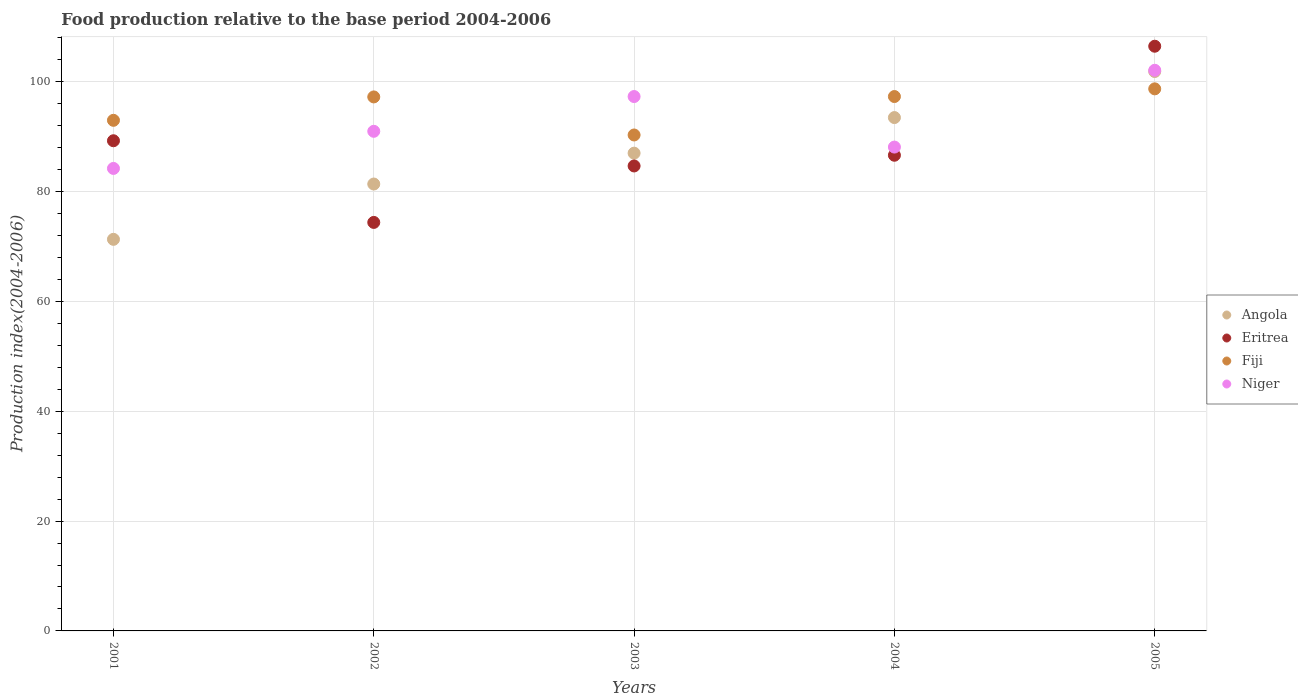How many different coloured dotlines are there?
Provide a succinct answer. 4. Is the number of dotlines equal to the number of legend labels?
Your answer should be compact. Yes. What is the food production index in Eritrea in 2001?
Provide a succinct answer. 89.25. Across all years, what is the maximum food production index in Niger?
Your answer should be very brief. 102.08. Across all years, what is the minimum food production index in Eritrea?
Offer a terse response. 74.38. In which year was the food production index in Niger maximum?
Your answer should be compact. 2005. In which year was the food production index in Angola minimum?
Give a very brief answer. 2001. What is the total food production index in Eritrea in the graph?
Your response must be concise. 441.36. What is the difference between the food production index in Angola in 2003 and that in 2005?
Ensure brevity in your answer.  -14.87. What is the difference between the food production index in Eritrea in 2002 and the food production index in Angola in 2005?
Ensure brevity in your answer.  -27.48. What is the average food production index in Niger per year?
Your answer should be very brief. 92.53. In the year 2003, what is the difference between the food production index in Angola and food production index in Fiji?
Keep it short and to the point. -3.31. In how many years, is the food production index in Angola greater than 4?
Ensure brevity in your answer.  5. What is the ratio of the food production index in Niger in 2003 to that in 2005?
Give a very brief answer. 0.95. What is the difference between the highest and the second highest food production index in Eritrea?
Make the answer very short. 17.21. What is the difference between the highest and the lowest food production index in Fiji?
Make the answer very short. 8.4. Is it the case that in every year, the sum of the food production index in Niger and food production index in Fiji  is greater than the sum of food production index in Angola and food production index in Eritrea?
Keep it short and to the point. No. Is the food production index in Fiji strictly greater than the food production index in Niger over the years?
Your answer should be very brief. No. How many dotlines are there?
Offer a very short reply. 4. What is the difference between two consecutive major ticks on the Y-axis?
Provide a succinct answer. 20. Are the values on the major ticks of Y-axis written in scientific E-notation?
Give a very brief answer. No. Does the graph contain grids?
Give a very brief answer. Yes. How are the legend labels stacked?
Give a very brief answer. Vertical. What is the title of the graph?
Keep it short and to the point. Food production relative to the base period 2004-2006. What is the label or title of the X-axis?
Your answer should be very brief. Years. What is the label or title of the Y-axis?
Your answer should be very brief. Production index(2004-2006). What is the Production index(2004-2006) in Angola in 2001?
Offer a very short reply. 71.3. What is the Production index(2004-2006) of Eritrea in 2001?
Offer a very short reply. 89.25. What is the Production index(2004-2006) in Fiji in 2001?
Keep it short and to the point. 92.97. What is the Production index(2004-2006) of Niger in 2001?
Offer a very short reply. 84.21. What is the Production index(2004-2006) in Angola in 2002?
Ensure brevity in your answer.  81.37. What is the Production index(2004-2006) of Eritrea in 2002?
Provide a succinct answer. 74.38. What is the Production index(2004-2006) of Fiji in 2002?
Give a very brief answer. 97.23. What is the Production index(2004-2006) in Niger in 2002?
Keep it short and to the point. 90.97. What is the Production index(2004-2006) in Angola in 2003?
Provide a succinct answer. 86.99. What is the Production index(2004-2006) in Eritrea in 2003?
Your answer should be very brief. 84.66. What is the Production index(2004-2006) of Fiji in 2003?
Your answer should be very brief. 90.3. What is the Production index(2004-2006) in Niger in 2003?
Ensure brevity in your answer.  97.3. What is the Production index(2004-2006) in Angola in 2004?
Your answer should be compact. 93.47. What is the Production index(2004-2006) in Eritrea in 2004?
Offer a very short reply. 86.61. What is the Production index(2004-2006) of Fiji in 2004?
Your answer should be very brief. 97.3. What is the Production index(2004-2006) in Niger in 2004?
Ensure brevity in your answer.  88.1. What is the Production index(2004-2006) in Angola in 2005?
Provide a succinct answer. 101.86. What is the Production index(2004-2006) in Eritrea in 2005?
Make the answer very short. 106.46. What is the Production index(2004-2006) in Fiji in 2005?
Provide a succinct answer. 98.7. What is the Production index(2004-2006) of Niger in 2005?
Offer a terse response. 102.08. Across all years, what is the maximum Production index(2004-2006) in Angola?
Keep it short and to the point. 101.86. Across all years, what is the maximum Production index(2004-2006) in Eritrea?
Your response must be concise. 106.46. Across all years, what is the maximum Production index(2004-2006) of Fiji?
Give a very brief answer. 98.7. Across all years, what is the maximum Production index(2004-2006) of Niger?
Give a very brief answer. 102.08. Across all years, what is the minimum Production index(2004-2006) of Angola?
Keep it short and to the point. 71.3. Across all years, what is the minimum Production index(2004-2006) in Eritrea?
Keep it short and to the point. 74.38. Across all years, what is the minimum Production index(2004-2006) in Fiji?
Offer a terse response. 90.3. Across all years, what is the minimum Production index(2004-2006) of Niger?
Give a very brief answer. 84.21. What is the total Production index(2004-2006) of Angola in the graph?
Offer a very short reply. 434.99. What is the total Production index(2004-2006) in Eritrea in the graph?
Your response must be concise. 441.36. What is the total Production index(2004-2006) of Fiji in the graph?
Provide a succinct answer. 476.5. What is the total Production index(2004-2006) in Niger in the graph?
Provide a short and direct response. 462.66. What is the difference between the Production index(2004-2006) in Angola in 2001 and that in 2002?
Offer a very short reply. -10.07. What is the difference between the Production index(2004-2006) in Eritrea in 2001 and that in 2002?
Provide a short and direct response. 14.87. What is the difference between the Production index(2004-2006) in Fiji in 2001 and that in 2002?
Provide a succinct answer. -4.26. What is the difference between the Production index(2004-2006) of Niger in 2001 and that in 2002?
Your answer should be very brief. -6.76. What is the difference between the Production index(2004-2006) in Angola in 2001 and that in 2003?
Your answer should be very brief. -15.69. What is the difference between the Production index(2004-2006) in Eritrea in 2001 and that in 2003?
Offer a terse response. 4.59. What is the difference between the Production index(2004-2006) in Fiji in 2001 and that in 2003?
Your answer should be very brief. 2.67. What is the difference between the Production index(2004-2006) of Niger in 2001 and that in 2003?
Offer a very short reply. -13.09. What is the difference between the Production index(2004-2006) in Angola in 2001 and that in 2004?
Make the answer very short. -22.17. What is the difference between the Production index(2004-2006) of Eritrea in 2001 and that in 2004?
Your response must be concise. 2.64. What is the difference between the Production index(2004-2006) of Fiji in 2001 and that in 2004?
Keep it short and to the point. -4.33. What is the difference between the Production index(2004-2006) of Niger in 2001 and that in 2004?
Make the answer very short. -3.89. What is the difference between the Production index(2004-2006) of Angola in 2001 and that in 2005?
Make the answer very short. -30.56. What is the difference between the Production index(2004-2006) of Eritrea in 2001 and that in 2005?
Your answer should be very brief. -17.21. What is the difference between the Production index(2004-2006) of Fiji in 2001 and that in 2005?
Your answer should be very brief. -5.73. What is the difference between the Production index(2004-2006) in Niger in 2001 and that in 2005?
Give a very brief answer. -17.87. What is the difference between the Production index(2004-2006) of Angola in 2002 and that in 2003?
Your response must be concise. -5.62. What is the difference between the Production index(2004-2006) in Eritrea in 2002 and that in 2003?
Keep it short and to the point. -10.28. What is the difference between the Production index(2004-2006) of Fiji in 2002 and that in 2003?
Offer a terse response. 6.93. What is the difference between the Production index(2004-2006) of Niger in 2002 and that in 2003?
Give a very brief answer. -6.33. What is the difference between the Production index(2004-2006) in Angola in 2002 and that in 2004?
Make the answer very short. -12.1. What is the difference between the Production index(2004-2006) in Eritrea in 2002 and that in 2004?
Provide a short and direct response. -12.23. What is the difference between the Production index(2004-2006) in Fiji in 2002 and that in 2004?
Keep it short and to the point. -0.07. What is the difference between the Production index(2004-2006) in Niger in 2002 and that in 2004?
Offer a very short reply. 2.87. What is the difference between the Production index(2004-2006) in Angola in 2002 and that in 2005?
Offer a very short reply. -20.49. What is the difference between the Production index(2004-2006) of Eritrea in 2002 and that in 2005?
Your answer should be compact. -32.08. What is the difference between the Production index(2004-2006) of Fiji in 2002 and that in 2005?
Your response must be concise. -1.47. What is the difference between the Production index(2004-2006) in Niger in 2002 and that in 2005?
Provide a short and direct response. -11.11. What is the difference between the Production index(2004-2006) in Angola in 2003 and that in 2004?
Provide a short and direct response. -6.48. What is the difference between the Production index(2004-2006) in Eritrea in 2003 and that in 2004?
Offer a very short reply. -1.95. What is the difference between the Production index(2004-2006) of Niger in 2003 and that in 2004?
Make the answer very short. 9.2. What is the difference between the Production index(2004-2006) of Angola in 2003 and that in 2005?
Your answer should be compact. -14.87. What is the difference between the Production index(2004-2006) of Eritrea in 2003 and that in 2005?
Your answer should be compact. -21.8. What is the difference between the Production index(2004-2006) of Niger in 2003 and that in 2005?
Keep it short and to the point. -4.78. What is the difference between the Production index(2004-2006) of Angola in 2004 and that in 2005?
Make the answer very short. -8.39. What is the difference between the Production index(2004-2006) of Eritrea in 2004 and that in 2005?
Offer a very short reply. -19.85. What is the difference between the Production index(2004-2006) in Fiji in 2004 and that in 2005?
Make the answer very short. -1.4. What is the difference between the Production index(2004-2006) of Niger in 2004 and that in 2005?
Your answer should be compact. -13.98. What is the difference between the Production index(2004-2006) in Angola in 2001 and the Production index(2004-2006) in Eritrea in 2002?
Provide a short and direct response. -3.08. What is the difference between the Production index(2004-2006) in Angola in 2001 and the Production index(2004-2006) in Fiji in 2002?
Your answer should be very brief. -25.93. What is the difference between the Production index(2004-2006) of Angola in 2001 and the Production index(2004-2006) of Niger in 2002?
Give a very brief answer. -19.67. What is the difference between the Production index(2004-2006) of Eritrea in 2001 and the Production index(2004-2006) of Fiji in 2002?
Provide a short and direct response. -7.98. What is the difference between the Production index(2004-2006) in Eritrea in 2001 and the Production index(2004-2006) in Niger in 2002?
Provide a short and direct response. -1.72. What is the difference between the Production index(2004-2006) in Fiji in 2001 and the Production index(2004-2006) in Niger in 2002?
Keep it short and to the point. 2. What is the difference between the Production index(2004-2006) in Angola in 2001 and the Production index(2004-2006) in Eritrea in 2003?
Your response must be concise. -13.36. What is the difference between the Production index(2004-2006) of Angola in 2001 and the Production index(2004-2006) of Fiji in 2003?
Ensure brevity in your answer.  -19. What is the difference between the Production index(2004-2006) in Eritrea in 2001 and the Production index(2004-2006) in Fiji in 2003?
Provide a succinct answer. -1.05. What is the difference between the Production index(2004-2006) of Eritrea in 2001 and the Production index(2004-2006) of Niger in 2003?
Ensure brevity in your answer.  -8.05. What is the difference between the Production index(2004-2006) of Fiji in 2001 and the Production index(2004-2006) of Niger in 2003?
Keep it short and to the point. -4.33. What is the difference between the Production index(2004-2006) in Angola in 2001 and the Production index(2004-2006) in Eritrea in 2004?
Give a very brief answer. -15.31. What is the difference between the Production index(2004-2006) in Angola in 2001 and the Production index(2004-2006) in Niger in 2004?
Ensure brevity in your answer.  -16.8. What is the difference between the Production index(2004-2006) of Eritrea in 2001 and the Production index(2004-2006) of Fiji in 2004?
Your answer should be compact. -8.05. What is the difference between the Production index(2004-2006) in Eritrea in 2001 and the Production index(2004-2006) in Niger in 2004?
Give a very brief answer. 1.15. What is the difference between the Production index(2004-2006) of Fiji in 2001 and the Production index(2004-2006) of Niger in 2004?
Provide a succinct answer. 4.87. What is the difference between the Production index(2004-2006) in Angola in 2001 and the Production index(2004-2006) in Eritrea in 2005?
Provide a succinct answer. -35.16. What is the difference between the Production index(2004-2006) in Angola in 2001 and the Production index(2004-2006) in Fiji in 2005?
Provide a succinct answer. -27.4. What is the difference between the Production index(2004-2006) of Angola in 2001 and the Production index(2004-2006) of Niger in 2005?
Keep it short and to the point. -30.78. What is the difference between the Production index(2004-2006) in Eritrea in 2001 and the Production index(2004-2006) in Fiji in 2005?
Your answer should be very brief. -9.45. What is the difference between the Production index(2004-2006) of Eritrea in 2001 and the Production index(2004-2006) of Niger in 2005?
Your response must be concise. -12.83. What is the difference between the Production index(2004-2006) of Fiji in 2001 and the Production index(2004-2006) of Niger in 2005?
Offer a terse response. -9.11. What is the difference between the Production index(2004-2006) in Angola in 2002 and the Production index(2004-2006) in Eritrea in 2003?
Keep it short and to the point. -3.29. What is the difference between the Production index(2004-2006) of Angola in 2002 and the Production index(2004-2006) of Fiji in 2003?
Your answer should be very brief. -8.93. What is the difference between the Production index(2004-2006) of Angola in 2002 and the Production index(2004-2006) of Niger in 2003?
Offer a terse response. -15.93. What is the difference between the Production index(2004-2006) of Eritrea in 2002 and the Production index(2004-2006) of Fiji in 2003?
Your answer should be compact. -15.92. What is the difference between the Production index(2004-2006) of Eritrea in 2002 and the Production index(2004-2006) of Niger in 2003?
Provide a succinct answer. -22.92. What is the difference between the Production index(2004-2006) in Fiji in 2002 and the Production index(2004-2006) in Niger in 2003?
Your answer should be very brief. -0.07. What is the difference between the Production index(2004-2006) in Angola in 2002 and the Production index(2004-2006) in Eritrea in 2004?
Offer a terse response. -5.24. What is the difference between the Production index(2004-2006) in Angola in 2002 and the Production index(2004-2006) in Fiji in 2004?
Keep it short and to the point. -15.93. What is the difference between the Production index(2004-2006) in Angola in 2002 and the Production index(2004-2006) in Niger in 2004?
Provide a succinct answer. -6.73. What is the difference between the Production index(2004-2006) in Eritrea in 2002 and the Production index(2004-2006) in Fiji in 2004?
Offer a terse response. -22.92. What is the difference between the Production index(2004-2006) of Eritrea in 2002 and the Production index(2004-2006) of Niger in 2004?
Offer a terse response. -13.72. What is the difference between the Production index(2004-2006) in Fiji in 2002 and the Production index(2004-2006) in Niger in 2004?
Ensure brevity in your answer.  9.13. What is the difference between the Production index(2004-2006) in Angola in 2002 and the Production index(2004-2006) in Eritrea in 2005?
Your response must be concise. -25.09. What is the difference between the Production index(2004-2006) in Angola in 2002 and the Production index(2004-2006) in Fiji in 2005?
Keep it short and to the point. -17.33. What is the difference between the Production index(2004-2006) in Angola in 2002 and the Production index(2004-2006) in Niger in 2005?
Give a very brief answer. -20.71. What is the difference between the Production index(2004-2006) of Eritrea in 2002 and the Production index(2004-2006) of Fiji in 2005?
Provide a succinct answer. -24.32. What is the difference between the Production index(2004-2006) in Eritrea in 2002 and the Production index(2004-2006) in Niger in 2005?
Ensure brevity in your answer.  -27.7. What is the difference between the Production index(2004-2006) in Fiji in 2002 and the Production index(2004-2006) in Niger in 2005?
Give a very brief answer. -4.85. What is the difference between the Production index(2004-2006) in Angola in 2003 and the Production index(2004-2006) in Eritrea in 2004?
Your answer should be compact. 0.38. What is the difference between the Production index(2004-2006) in Angola in 2003 and the Production index(2004-2006) in Fiji in 2004?
Your response must be concise. -10.31. What is the difference between the Production index(2004-2006) of Angola in 2003 and the Production index(2004-2006) of Niger in 2004?
Ensure brevity in your answer.  -1.11. What is the difference between the Production index(2004-2006) of Eritrea in 2003 and the Production index(2004-2006) of Fiji in 2004?
Provide a succinct answer. -12.64. What is the difference between the Production index(2004-2006) of Eritrea in 2003 and the Production index(2004-2006) of Niger in 2004?
Keep it short and to the point. -3.44. What is the difference between the Production index(2004-2006) of Angola in 2003 and the Production index(2004-2006) of Eritrea in 2005?
Give a very brief answer. -19.47. What is the difference between the Production index(2004-2006) of Angola in 2003 and the Production index(2004-2006) of Fiji in 2005?
Make the answer very short. -11.71. What is the difference between the Production index(2004-2006) of Angola in 2003 and the Production index(2004-2006) of Niger in 2005?
Ensure brevity in your answer.  -15.09. What is the difference between the Production index(2004-2006) in Eritrea in 2003 and the Production index(2004-2006) in Fiji in 2005?
Provide a succinct answer. -14.04. What is the difference between the Production index(2004-2006) of Eritrea in 2003 and the Production index(2004-2006) of Niger in 2005?
Provide a short and direct response. -17.42. What is the difference between the Production index(2004-2006) in Fiji in 2003 and the Production index(2004-2006) in Niger in 2005?
Make the answer very short. -11.78. What is the difference between the Production index(2004-2006) of Angola in 2004 and the Production index(2004-2006) of Eritrea in 2005?
Give a very brief answer. -12.99. What is the difference between the Production index(2004-2006) of Angola in 2004 and the Production index(2004-2006) of Fiji in 2005?
Offer a very short reply. -5.23. What is the difference between the Production index(2004-2006) in Angola in 2004 and the Production index(2004-2006) in Niger in 2005?
Your response must be concise. -8.61. What is the difference between the Production index(2004-2006) in Eritrea in 2004 and the Production index(2004-2006) in Fiji in 2005?
Provide a short and direct response. -12.09. What is the difference between the Production index(2004-2006) of Eritrea in 2004 and the Production index(2004-2006) of Niger in 2005?
Your response must be concise. -15.47. What is the difference between the Production index(2004-2006) of Fiji in 2004 and the Production index(2004-2006) of Niger in 2005?
Make the answer very short. -4.78. What is the average Production index(2004-2006) in Angola per year?
Provide a short and direct response. 87. What is the average Production index(2004-2006) in Eritrea per year?
Offer a very short reply. 88.27. What is the average Production index(2004-2006) of Fiji per year?
Offer a terse response. 95.3. What is the average Production index(2004-2006) in Niger per year?
Your response must be concise. 92.53. In the year 2001, what is the difference between the Production index(2004-2006) of Angola and Production index(2004-2006) of Eritrea?
Your response must be concise. -17.95. In the year 2001, what is the difference between the Production index(2004-2006) in Angola and Production index(2004-2006) in Fiji?
Offer a terse response. -21.67. In the year 2001, what is the difference between the Production index(2004-2006) of Angola and Production index(2004-2006) of Niger?
Offer a terse response. -12.91. In the year 2001, what is the difference between the Production index(2004-2006) in Eritrea and Production index(2004-2006) in Fiji?
Keep it short and to the point. -3.72. In the year 2001, what is the difference between the Production index(2004-2006) in Eritrea and Production index(2004-2006) in Niger?
Provide a succinct answer. 5.04. In the year 2001, what is the difference between the Production index(2004-2006) of Fiji and Production index(2004-2006) of Niger?
Provide a short and direct response. 8.76. In the year 2002, what is the difference between the Production index(2004-2006) of Angola and Production index(2004-2006) of Eritrea?
Offer a very short reply. 6.99. In the year 2002, what is the difference between the Production index(2004-2006) in Angola and Production index(2004-2006) in Fiji?
Offer a very short reply. -15.86. In the year 2002, what is the difference between the Production index(2004-2006) of Eritrea and Production index(2004-2006) of Fiji?
Make the answer very short. -22.85. In the year 2002, what is the difference between the Production index(2004-2006) of Eritrea and Production index(2004-2006) of Niger?
Provide a succinct answer. -16.59. In the year 2002, what is the difference between the Production index(2004-2006) of Fiji and Production index(2004-2006) of Niger?
Ensure brevity in your answer.  6.26. In the year 2003, what is the difference between the Production index(2004-2006) in Angola and Production index(2004-2006) in Eritrea?
Your answer should be compact. 2.33. In the year 2003, what is the difference between the Production index(2004-2006) in Angola and Production index(2004-2006) in Fiji?
Your response must be concise. -3.31. In the year 2003, what is the difference between the Production index(2004-2006) in Angola and Production index(2004-2006) in Niger?
Your response must be concise. -10.31. In the year 2003, what is the difference between the Production index(2004-2006) in Eritrea and Production index(2004-2006) in Fiji?
Give a very brief answer. -5.64. In the year 2003, what is the difference between the Production index(2004-2006) in Eritrea and Production index(2004-2006) in Niger?
Give a very brief answer. -12.64. In the year 2003, what is the difference between the Production index(2004-2006) in Fiji and Production index(2004-2006) in Niger?
Offer a very short reply. -7. In the year 2004, what is the difference between the Production index(2004-2006) of Angola and Production index(2004-2006) of Eritrea?
Give a very brief answer. 6.86. In the year 2004, what is the difference between the Production index(2004-2006) in Angola and Production index(2004-2006) in Fiji?
Offer a very short reply. -3.83. In the year 2004, what is the difference between the Production index(2004-2006) of Angola and Production index(2004-2006) of Niger?
Make the answer very short. 5.37. In the year 2004, what is the difference between the Production index(2004-2006) in Eritrea and Production index(2004-2006) in Fiji?
Your response must be concise. -10.69. In the year 2004, what is the difference between the Production index(2004-2006) in Eritrea and Production index(2004-2006) in Niger?
Provide a succinct answer. -1.49. In the year 2005, what is the difference between the Production index(2004-2006) in Angola and Production index(2004-2006) in Eritrea?
Keep it short and to the point. -4.6. In the year 2005, what is the difference between the Production index(2004-2006) in Angola and Production index(2004-2006) in Fiji?
Your answer should be compact. 3.16. In the year 2005, what is the difference between the Production index(2004-2006) of Angola and Production index(2004-2006) of Niger?
Your response must be concise. -0.22. In the year 2005, what is the difference between the Production index(2004-2006) of Eritrea and Production index(2004-2006) of Fiji?
Offer a terse response. 7.76. In the year 2005, what is the difference between the Production index(2004-2006) in Eritrea and Production index(2004-2006) in Niger?
Give a very brief answer. 4.38. In the year 2005, what is the difference between the Production index(2004-2006) of Fiji and Production index(2004-2006) of Niger?
Make the answer very short. -3.38. What is the ratio of the Production index(2004-2006) in Angola in 2001 to that in 2002?
Provide a succinct answer. 0.88. What is the ratio of the Production index(2004-2006) of Eritrea in 2001 to that in 2002?
Provide a short and direct response. 1.2. What is the ratio of the Production index(2004-2006) in Fiji in 2001 to that in 2002?
Make the answer very short. 0.96. What is the ratio of the Production index(2004-2006) in Niger in 2001 to that in 2002?
Ensure brevity in your answer.  0.93. What is the ratio of the Production index(2004-2006) of Angola in 2001 to that in 2003?
Offer a very short reply. 0.82. What is the ratio of the Production index(2004-2006) in Eritrea in 2001 to that in 2003?
Your answer should be very brief. 1.05. What is the ratio of the Production index(2004-2006) of Fiji in 2001 to that in 2003?
Ensure brevity in your answer.  1.03. What is the ratio of the Production index(2004-2006) of Niger in 2001 to that in 2003?
Provide a succinct answer. 0.87. What is the ratio of the Production index(2004-2006) of Angola in 2001 to that in 2004?
Your response must be concise. 0.76. What is the ratio of the Production index(2004-2006) of Eritrea in 2001 to that in 2004?
Provide a short and direct response. 1.03. What is the ratio of the Production index(2004-2006) of Fiji in 2001 to that in 2004?
Your answer should be compact. 0.96. What is the ratio of the Production index(2004-2006) of Niger in 2001 to that in 2004?
Make the answer very short. 0.96. What is the ratio of the Production index(2004-2006) of Angola in 2001 to that in 2005?
Offer a very short reply. 0.7. What is the ratio of the Production index(2004-2006) in Eritrea in 2001 to that in 2005?
Keep it short and to the point. 0.84. What is the ratio of the Production index(2004-2006) of Fiji in 2001 to that in 2005?
Ensure brevity in your answer.  0.94. What is the ratio of the Production index(2004-2006) in Niger in 2001 to that in 2005?
Make the answer very short. 0.82. What is the ratio of the Production index(2004-2006) in Angola in 2002 to that in 2003?
Keep it short and to the point. 0.94. What is the ratio of the Production index(2004-2006) of Eritrea in 2002 to that in 2003?
Give a very brief answer. 0.88. What is the ratio of the Production index(2004-2006) of Fiji in 2002 to that in 2003?
Provide a short and direct response. 1.08. What is the ratio of the Production index(2004-2006) of Niger in 2002 to that in 2003?
Offer a terse response. 0.93. What is the ratio of the Production index(2004-2006) in Angola in 2002 to that in 2004?
Ensure brevity in your answer.  0.87. What is the ratio of the Production index(2004-2006) of Eritrea in 2002 to that in 2004?
Keep it short and to the point. 0.86. What is the ratio of the Production index(2004-2006) in Niger in 2002 to that in 2004?
Your response must be concise. 1.03. What is the ratio of the Production index(2004-2006) in Angola in 2002 to that in 2005?
Offer a terse response. 0.8. What is the ratio of the Production index(2004-2006) in Eritrea in 2002 to that in 2005?
Make the answer very short. 0.7. What is the ratio of the Production index(2004-2006) in Fiji in 2002 to that in 2005?
Your answer should be very brief. 0.99. What is the ratio of the Production index(2004-2006) of Niger in 2002 to that in 2005?
Your answer should be very brief. 0.89. What is the ratio of the Production index(2004-2006) in Angola in 2003 to that in 2004?
Keep it short and to the point. 0.93. What is the ratio of the Production index(2004-2006) in Eritrea in 2003 to that in 2004?
Provide a succinct answer. 0.98. What is the ratio of the Production index(2004-2006) of Fiji in 2003 to that in 2004?
Provide a short and direct response. 0.93. What is the ratio of the Production index(2004-2006) in Niger in 2003 to that in 2004?
Offer a terse response. 1.1. What is the ratio of the Production index(2004-2006) in Angola in 2003 to that in 2005?
Offer a very short reply. 0.85. What is the ratio of the Production index(2004-2006) of Eritrea in 2003 to that in 2005?
Keep it short and to the point. 0.8. What is the ratio of the Production index(2004-2006) of Fiji in 2003 to that in 2005?
Offer a terse response. 0.91. What is the ratio of the Production index(2004-2006) in Niger in 2003 to that in 2005?
Ensure brevity in your answer.  0.95. What is the ratio of the Production index(2004-2006) in Angola in 2004 to that in 2005?
Provide a short and direct response. 0.92. What is the ratio of the Production index(2004-2006) of Eritrea in 2004 to that in 2005?
Ensure brevity in your answer.  0.81. What is the ratio of the Production index(2004-2006) of Fiji in 2004 to that in 2005?
Offer a terse response. 0.99. What is the ratio of the Production index(2004-2006) in Niger in 2004 to that in 2005?
Offer a very short reply. 0.86. What is the difference between the highest and the second highest Production index(2004-2006) of Angola?
Your answer should be very brief. 8.39. What is the difference between the highest and the second highest Production index(2004-2006) in Eritrea?
Keep it short and to the point. 17.21. What is the difference between the highest and the second highest Production index(2004-2006) in Fiji?
Make the answer very short. 1.4. What is the difference between the highest and the second highest Production index(2004-2006) of Niger?
Offer a terse response. 4.78. What is the difference between the highest and the lowest Production index(2004-2006) in Angola?
Your response must be concise. 30.56. What is the difference between the highest and the lowest Production index(2004-2006) of Eritrea?
Give a very brief answer. 32.08. What is the difference between the highest and the lowest Production index(2004-2006) of Niger?
Your answer should be very brief. 17.87. 